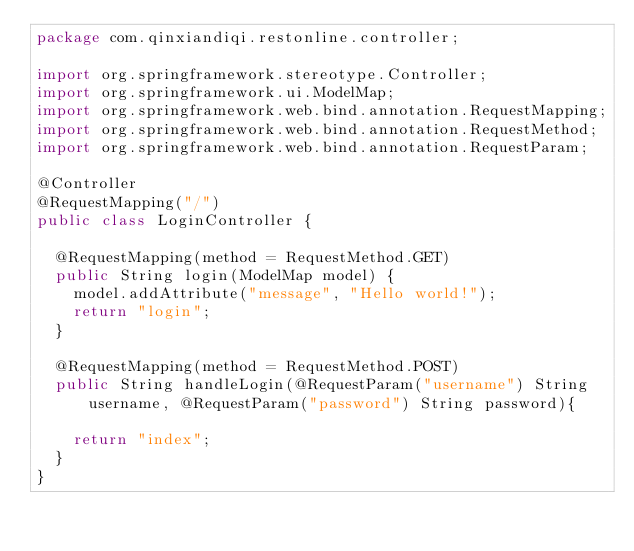<code> <loc_0><loc_0><loc_500><loc_500><_Java_>package com.qinxiandiqi.restonline.controller;

import org.springframework.stereotype.Controller;
import org.springframework.ui.ModelMap;
import org.springframework.web.bind.annotation.RequestMapping;
import org.springframework.web.bind.annotation.RequestMethod;
import org.springframework.web.bind.annotation.RequestParam;

@Controller
@RequestMapping("/")
public class LoginController {

	@RequestMapping(method = RequestMethod.GET)
	public String login(ModelMap model) {
		model.addAttribute("message", "Hello world!");
		return "login";
	}

	@RequestMapping(method = RequestMethod.POST)
	public String handleLogin(@RequestParam("username") String username, @RequestParam("password") String password){

		return "index";
	}
}</code> 